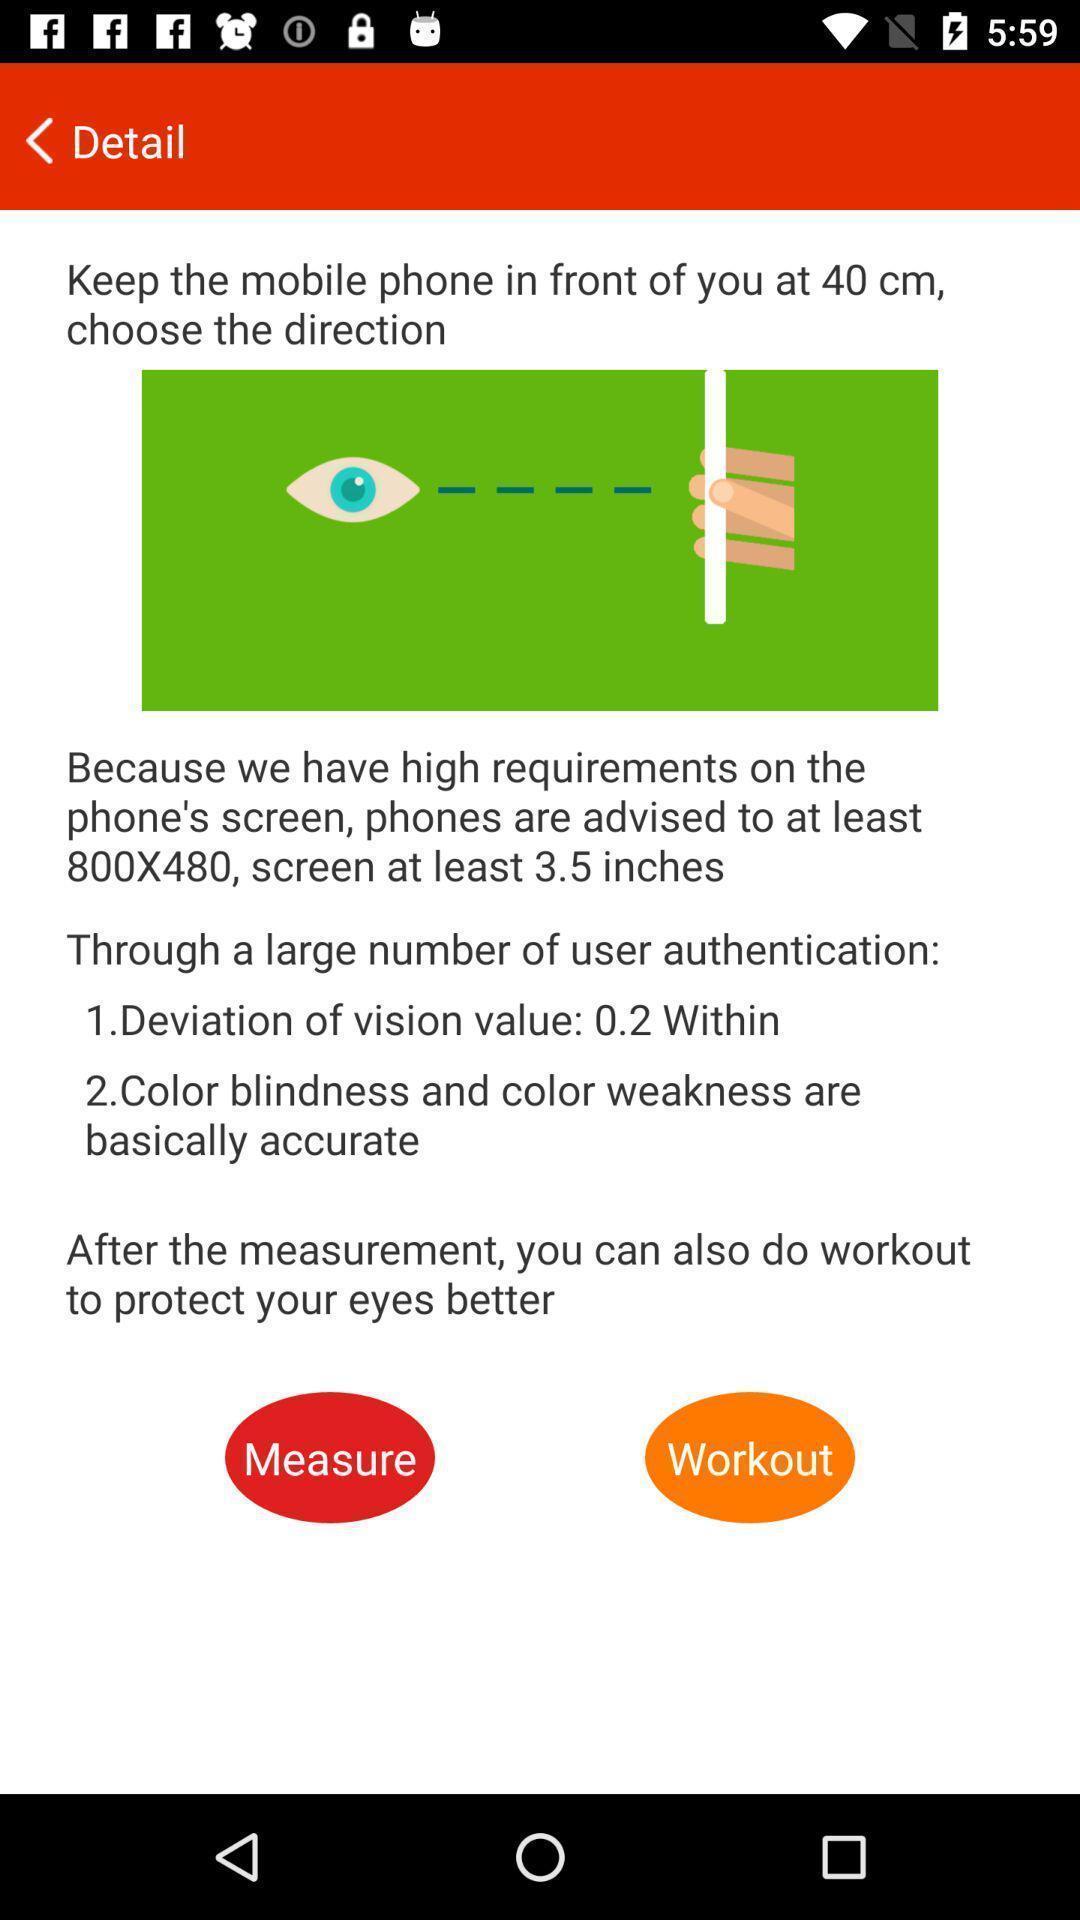Tell me what you see in this picture. Page showing information. 